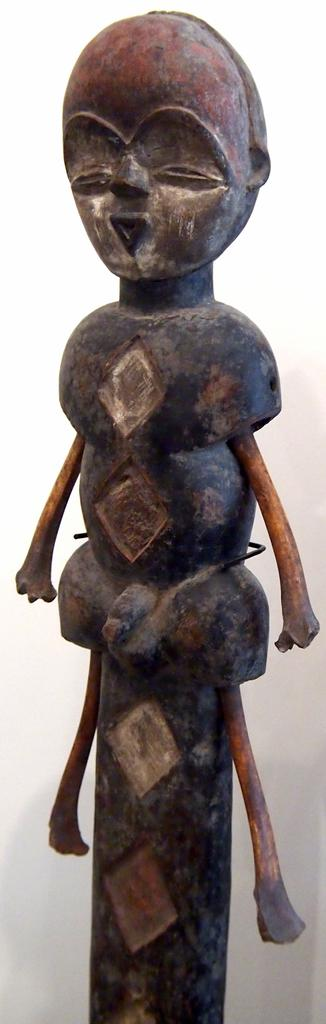What is the main subject of the image? There is a statue in the image. What color is the background of the image? The background of the image is white. How many thumbs can be seen on the statue in the image? There are no thumbs visible on the statue in the image, as it is a statue and not a living being. What level of experience does the beginner have in the image? There is no indication of a beginner or any level of experience in the image, as it only features a statue and a white background. 